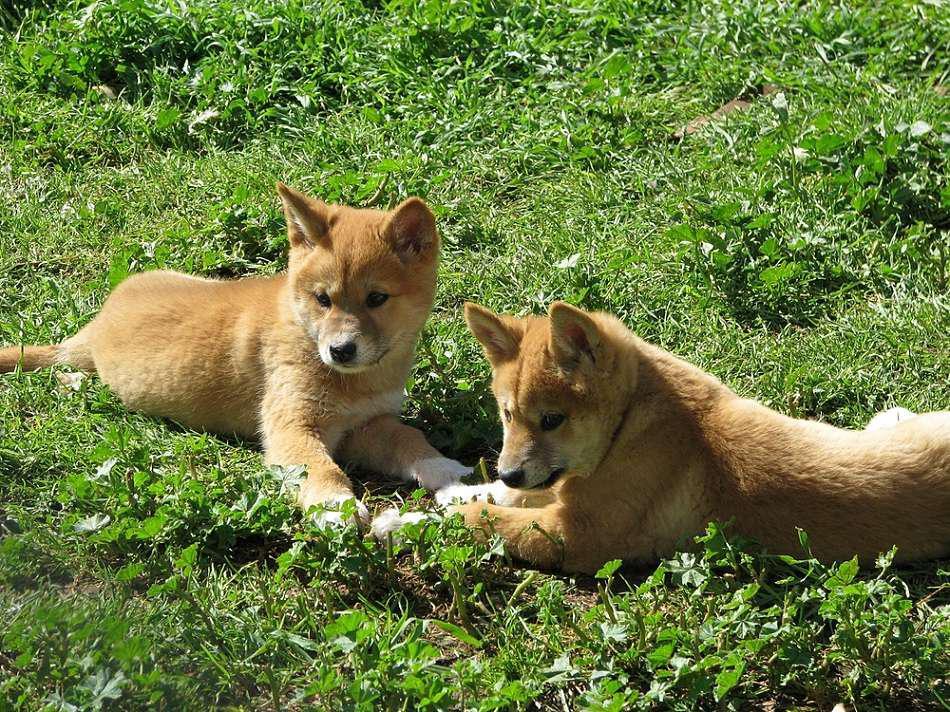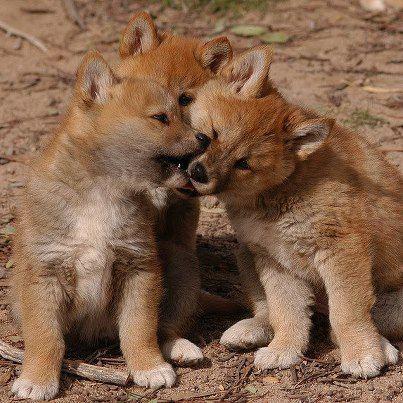The first image is the image on the left, the second image is the image on the right. Examine the images to the left and right. Is the description "Each image includes canine pups, and at least one image also includes at least one adult dog." accurate? Answer yes or no. No. The first image is the image on the left, the second image is the image on the right. Assess this claim about the two images: "Some of the animals in the image on the left are lying on the green grass.". Correct or not? Answer yes or no. Yes. 